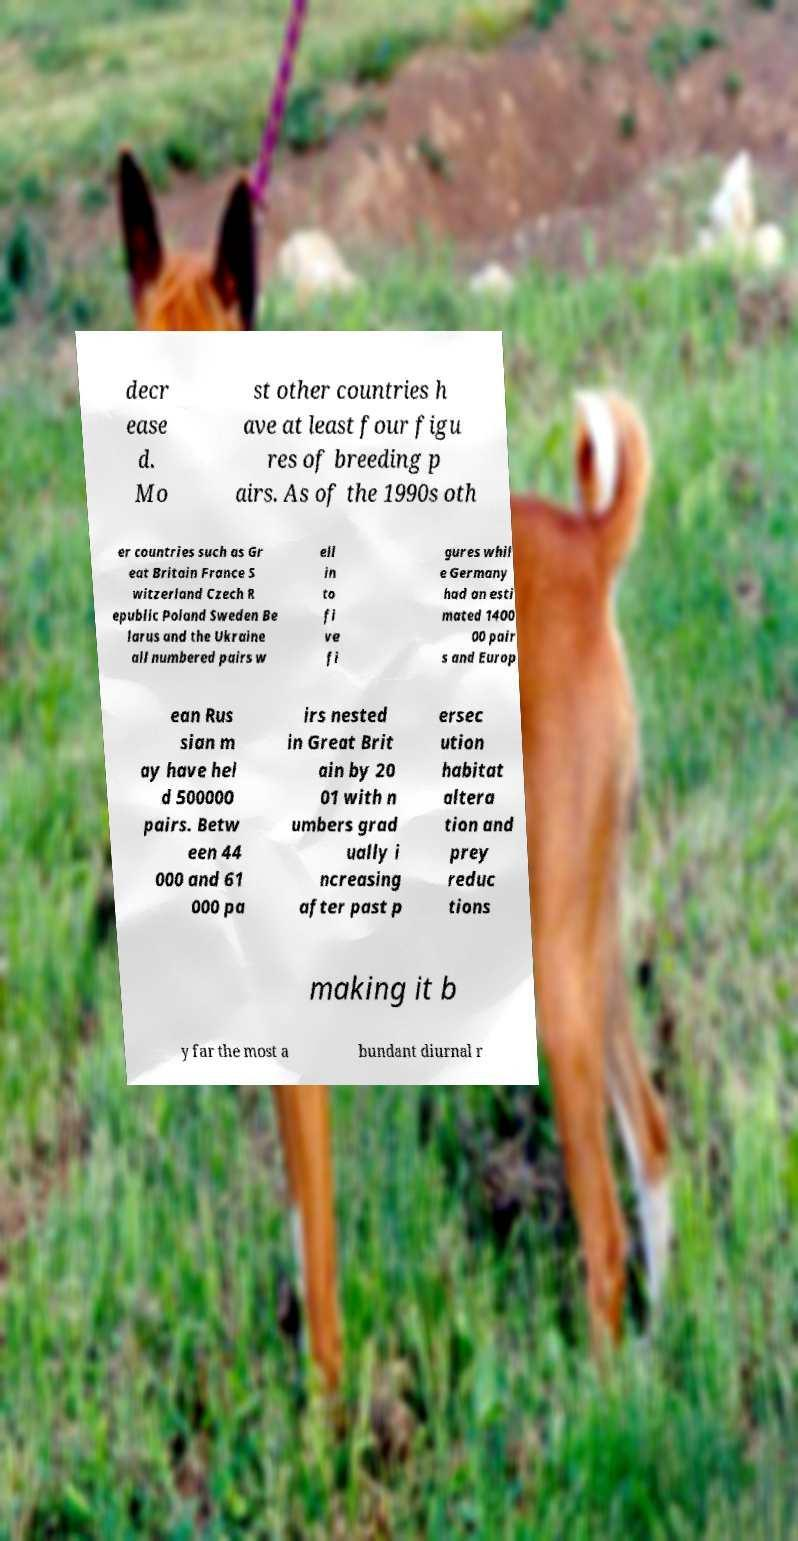Please read and relay the text visible in this image. What does it say? decr ease d. Mo st other countries h ave at least four figu res of breeding p airs. As of the 1990s oth er countries such as Gr eat Britain France S witzerland Czech R epublic Poland Sweden Be larus and the Ukraine all numbered pairs w ell in to fi ve fi gures whil e Germany had an esti mated 1400 00 pair s and Europ ean Rus sian m ay have hel d 500000 pairs. Betw een 44 000 and 61 000 pa irs nested in Great Brit ain by 20 01 with n umbers grad ually i ncreasing after past p ersec ution habitat altera tion and prey reduc tions making it b y far the most a bundant diurnal r 